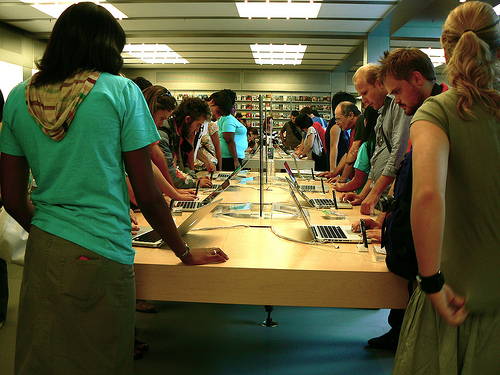<image>
Is the man in front of the girl? Yes. The man is positioned in front of the girl, appearing closer to the camera viewpoint. 